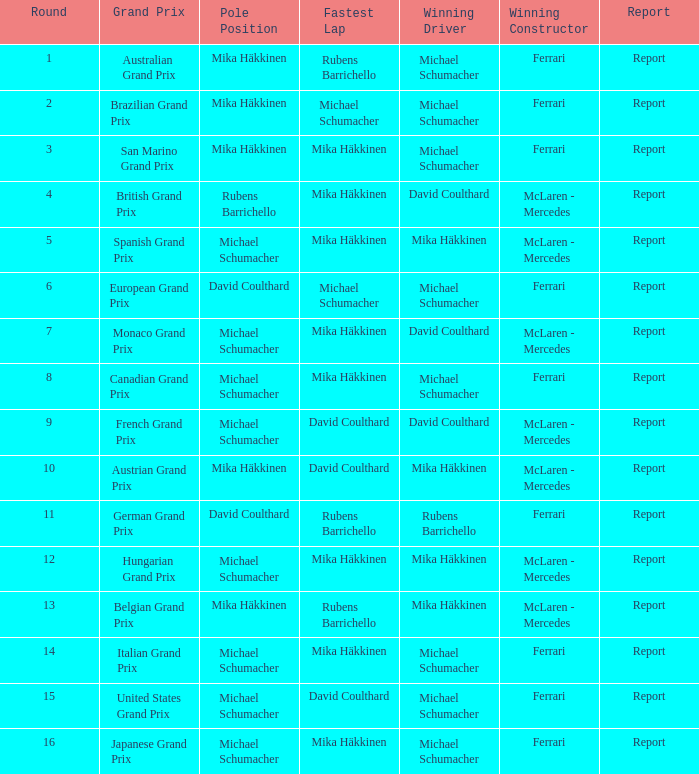In what round did michael schumacher hold the pole position, david coulthard complete the speediest lap, and mclaren - mercedes become the triumphant constructor? 1.0. 